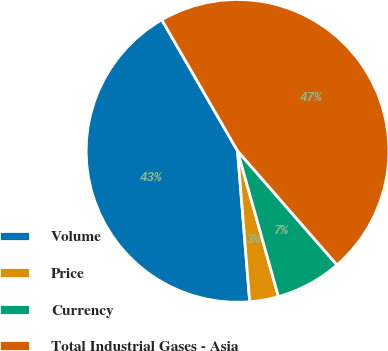Convert chart. <chart><loc_0><loc_0><loc_500><loc_500><pie_chart><fcel>Volume<fcel>Price<fcel>Currency<fcel>Total Industrial Gases - Asia<nl><fcel>42.94%<fcel>3.07%<fcel>7.06%<fcel>46.93%<nl></chart> 